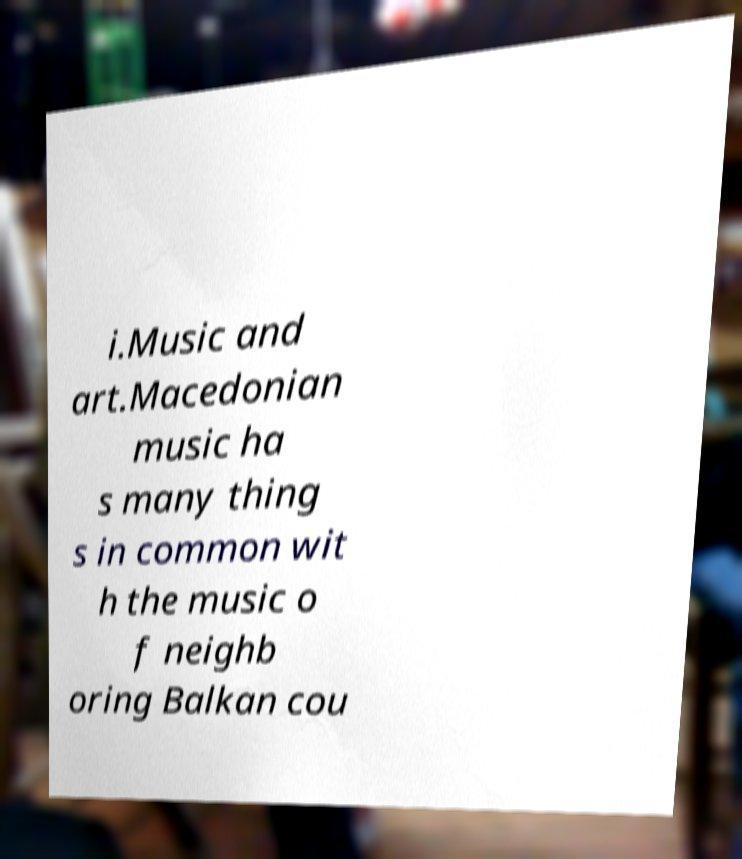Could you assist in decoding the text presented in this image and type it out clearly? i.Music and art.Macedonian music ha s many thing s in common wit h the music o f neighb oring Balkan cou 